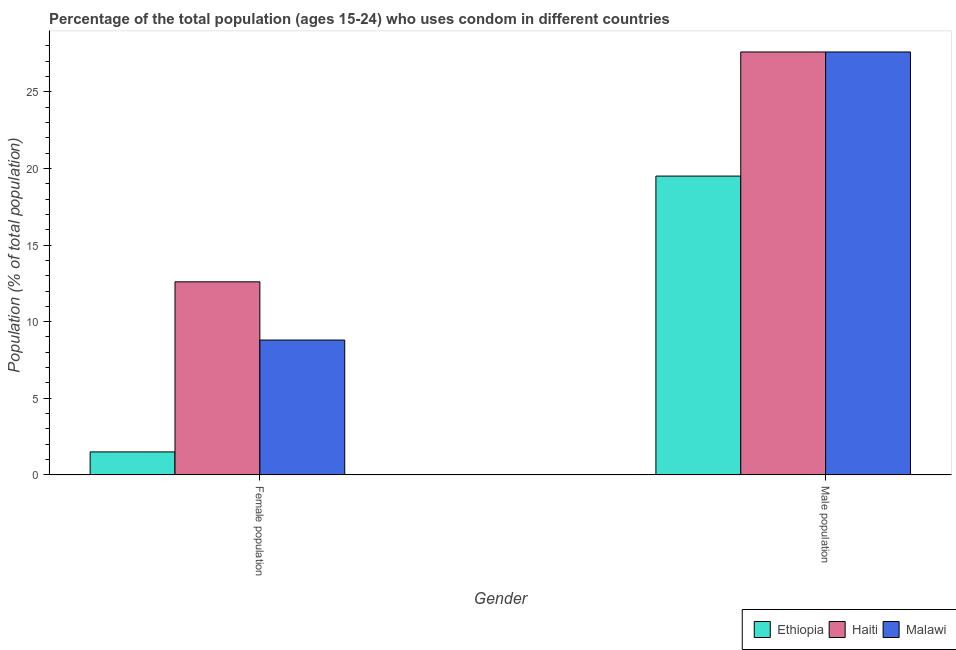Are the number of bars per tick equal to the number of legend labels?
Offer a terse response. Yes. Are the number of bars on each tick of the X-axis equal?
Your answer should be very brief. Yes. How many bars are there on the 1st tick from the left?
Ensure brevity in your answer.  3. What is the label of the 2nd group of bars from the left?
Your answer should be very brief. Male population. What is the female population in Haiti?
Keep it short and to the point. 12.6. In which country was the male population maximum?
Provide a short and direct response. Haiti. In which country was the male population minimum?
Offer a very short reply. Ethiopia. What is the total female population in the graph?
Your answer should be very brief. 22.9. What is the difference between the female population in Ethiopia and the male population in Malawi?
Your answer should be very brief. -26.1. What is the average female population per country?
Make the answer very short. 7.63. What is the difference between the female population and male population in Ethiopia?
Offer a very short reply. -18. What is the ratio of the male population in Haiti to that in Ethiopia?
Ensure brevity in your answer.  1.42. In how many countries, is the male population greater than the average male population taken over all countries?
Offer a very short reply. 2. What does the 3rd bar from the left in Male population represents?
Your response must be concise. Malawi. What does the 2nd bar from the right in Female population represents?
Keep it short and to the point. Haiti. How many bars are there?
Your response must be concise. 6. Are all the bars in the graph horizontal?
Provide a succinct answer. No. What is the difference between two consecutive major ticks on the Y-axis?
Give a very brief answer. 5. Does the graph contain grids?
Your answer should be very brief. No. How many legend labels are there?
Your response must be concise. 3. How are the legend labels stacked?
Offer a terse response. Horizontal. What is the title of the graph?
Provide a succinct answer. Percentage of the total population (ages 15-24) who uses condom in different countries. What is the label or title of the X-axis?
Keep it short and to the point. Gender. What is the label or title of the Y-axis?
Keep it short and to the point. Population (% of total population) . What is the Population (% of total population)  of Ethiopia in Female population?
Provide a short and direct response. 1.5. What is the Population (% of total population)  of Malawi in Female population?
Provide a succinct answer. 8.8. What is the Population (% of total population)  of Ethiopia in Male population?
Offer a very short reply. 19.5. What is the Population (% of total population)  in Haiti in Male population?
Your answer should be compact. 27.6. What is the Population (% of total population)  of Malawi in Male population?
Ensure brevity in your answer.  27.6. Across all Gender, what is the maximum Population (% of total population)  in Haiti?
Your answer should be very brief. 27.6. Across all Gender, what is the maximum Population (% of total population)  in Malawi?
Ensure brevity in your answer.  27.6. Across all Gender, what is the minimum Population (% of total population)  in Haiti?
Keep it short and to the point. 12.6. Across all Gender, what is the minimum Population (% of total population)  of Malawi?
Give a very brief answer. 8.8. What is the total Population (% of total population)  of Ethiopia in the graph?
Your response must be concise. 21. What is the total Population (% of total population)  of Haiti in the graph?
Offer a very short reply. 40.2. What is the total Population (% of total population)  in Malawi in the graph?
Offer a very short reply. 36.4. What is the difference between the Population (% of total population)  in Malawi in Female population and that in Male population?
Offer a very short reply. -18.8. What is the difference between the Population (% of total population)  in Ethiopia in Female population and the Population (% of total population)  in Haiti in Male population?
Make the answer very short. -26.1. What is the difference between the Population (% of total population)  of Ethiopia in Female population and the Population (% of total population)  of Malawi in Male population?
Keep it short and to the point. -26.1. What is the average Population (% of total population)  of Haiti per Gender?
Your answer should be very brief. 20.1. What is the difference between the Population (% of total population)  in Ethiopia and Population (% of total population)  in Haiti in Female population?
Ensure brevity in your answer.  -11.1. What is the difference between the Population (% of total population)  of Ethiopia and Population (% of total population)  of Haiti in Male population?
Provide a succinct answer. -8.1. What is the difference between the Population (% of total population)  in Ethiopia and Population (% of total population)  in Malawi in Male population?
Keep it short and to the point. -8.1. What is the ratio of the Population (% of total population)  of Ethiopia in Female population to that in Male population?
Make the answer very short. 0.08. What is the ratio of the Population (% of total population)  in Haiti in Female population to that in Male population?
Keep it short and to the point. 0.46. What is the ratio of the Population (% of total population)  of Malawi in Female population to that in Male population?
Ensure brevity in your answer.  0.32. What is the difference between the highest and the lowest Population (% of total population)  in Ethiopia?
Give a very brief answer. 18. What is the difference between the highest and the lowest Population (% of total population)  in Malawi?
Your answer should be compact. 18.8. 